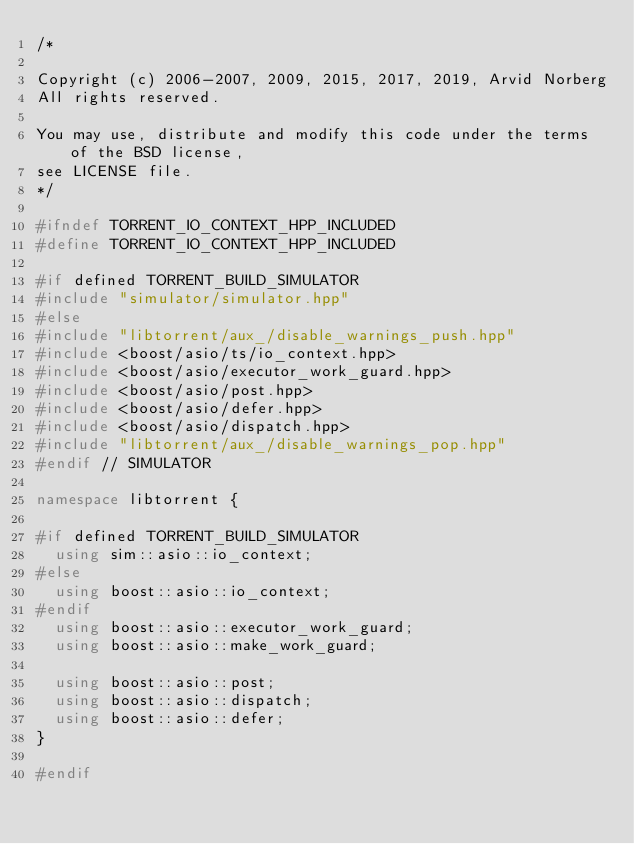Convert code to text. <code><loc_0><loc_0><loc_500><loc_500><_C++_>/*

Copyright (c) 2006-2007, 2009, 2015, 2017, 2019, Arvid Norberg
All rights reserved.

You may use, distribute and modify this code under the terms of the BSD license,
see LICENSE file.
*/

#ifndef TORRENT_IO_CONTEXT_HPP_INCLUDED
#define TORRENT_IO_CONTEXT_HPP_INCLUDED

#if defined TORRENT_BUILD_SIMULATOR
#include "simulator/simulator.hpp"
#else
#include "libtorrent/aux_/disable_warnings_push.hpp"
#include <boost/asio/ts/io_context.hpp>
#include <boost/asio/executor_work_guard.hpp>
#include <boost/asio/post.hpp>
#include <boost/asio/defer.hpp>
#include <boost/asio/dispatch.hpp>
#include "libtorrent/aux_/disable_warnings_pop.hpp"
#endif // SIMULATOR

namespace libtorrent {

#if defined TORRENT_BUILD_SIMULATOR
	using sim::asio::io_context;
#else
	using boost::asio::io_context;
#endif
	using boost::asio::executor_work_guard;
	using boost::asio::make_work_guard;

	using boost::asio::post;
	using boost::asio::dispatch;
	using boost::asio::defer;
}

#endif
</code> 